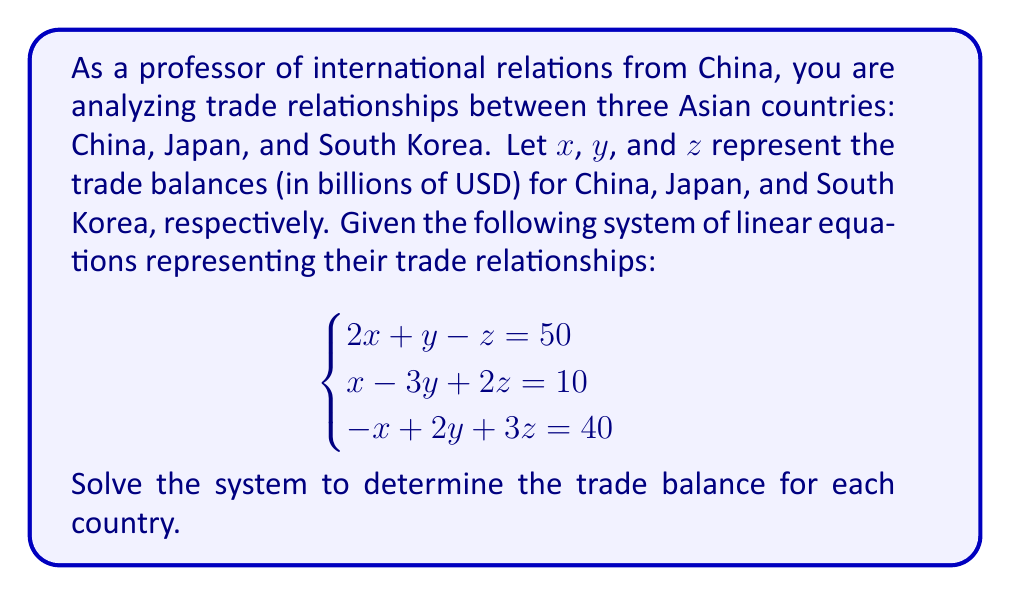Could you help me with this problem? To solve this system of linear equations, we'll use the elimination method:

1) First, let's eliminate $x$ from the first two equations:
   Multiply the first equation by 1 and the second by 2:
   $$\begin{cases}
   2x + y - z = 50 \\
   2x - 6y + 4z = 20
   \end{cases}$$
   
   Subtracting the second equation from the first:
   $$7y - 5z = 30 \quad (1)$$

2) Now, let's eliminate $x$ from the first and third equations:
   Add the first and third equations:
   $$3y + 2z = 90 \quad (2)$$

3) We now have two equations with two unknowns:
   $$\begin{cases}
   7y - 5z = 30 \quad (1) \\
   3y + 2z = 90 \quad (2)
   \end{cases}$$

4) Multiply equation (2) by 7 and equation (1) by 3:
   $$\begin{cases}
   21y + 14z = 630 \\
   21y - 15z = 90
   \end{cases}$$

5) Subtracting the second equation from the first:
   $$29z = 540$$
   $$z = 540 \div 29 \approx 18.62$$

6) Substitute this value of $z$ into equation (2):
   $$3y + 2(18.62) = 90$$
   $$3y + 37.24 = 90$$
   $$3y = 52.76$$
   $$y = 52.76 \div 3 \approx 17.59$$

7) Now substitute the values of $y$ and $z$ into the first original equation:
   $$2x + 17.59 - 18.62 = 50$$
   $$2x - 1.03 = 50$$
   $$2x = 51.03$$
   $$x = 51.03 \div 2 \approx 25.52$$

Therefore, the trade balances are:
China (x): $25.52 billion
Japan (y): $17.59 billion
South Korea (z): $18.62 billion
Answer: The trade balances (in billions of USD) are:
China: $25.52
Japan: $17.59
South Korea: $18.62 